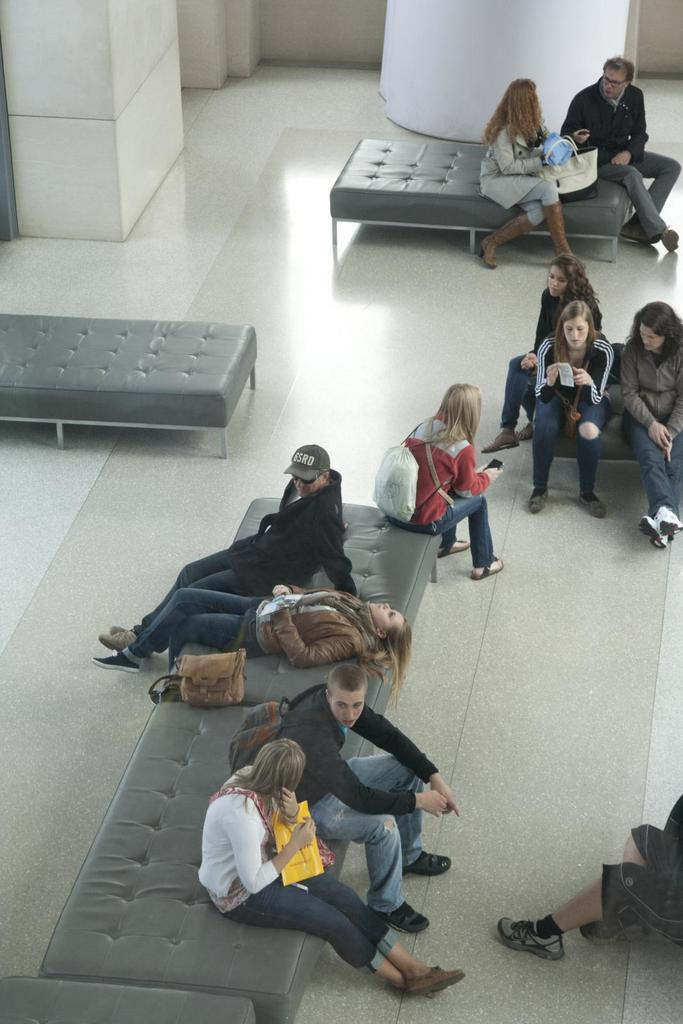What are the people in the image doing? The people in the image are sitting on a couch. What part of the room can be seen in the image? The floor is visible in the image. Can you see any volleyball players in the wilderness in the image? There are no volleyball players or wilderness present in the image; it features people sitting on a couch and a visible floor. 